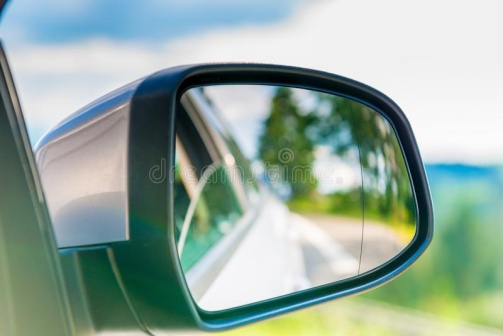Can you speculate why the driver might have chosen this particular route? The driver likely chose this picturesque route for its tranquility and natural beauty. Such roads, away from the hustle and bustle of city life, offer a refreshing change of pace, ideal for clearing one's mind or enjoying a leisurely drive. The presence of verdant trees and the well-maintained road condition also suggest that this route could be a favorite for those seeking solace in nature or perhaps a scenic detour off a main highway. What are some activities that might be enjoyable along this route? Traversing this route could be perfect for several activities, such as cycling, hiking nearby trails, or simply stopping at various points to enjoy the view. For photography enthusiasts, the scenic surroundings provide ample opportunities to capture the essence of the landscape. Additionally, small picnic spots or lookout points along the way could make for delightful stops to immerse oneself in the natural environment and take a break from the drive. 